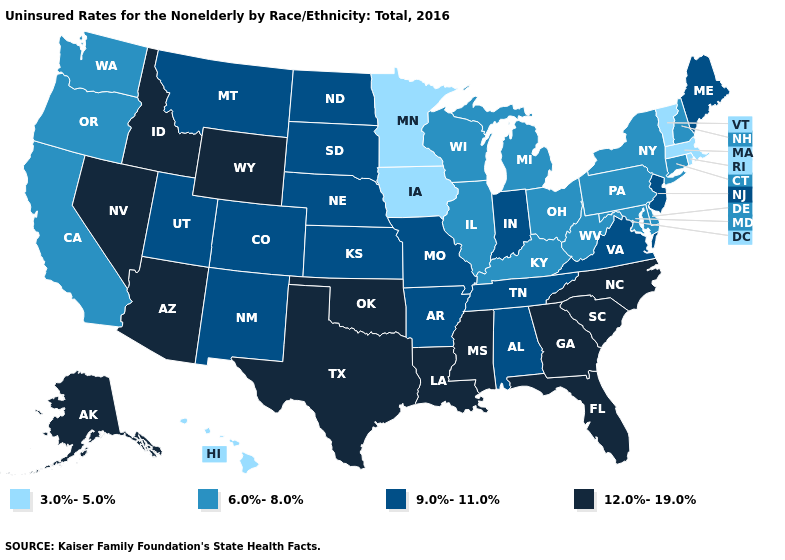Name the states that have a value in the range 12.0%-19.0%?
Concise answer only. Alaska, Arizona, Florida, Georgia, Idaho, Louisiana, Mississippi, Nevada, North Carolina, Oklahoma, South Carolina, Texas, Wyoming. Does Minnesota have the lowest value in the MidWest?
Keep it brief. Yes. Is the legend a continuous bar?
Give a very brief answer. No. What is the value of Texas?
Keep it brief. 12.0%-19.0%. Does Wyoming have a higher value than Louisiana?
Answer briefly. No. What is the lowest value in the Northeast?
Write a very short answer. 3.0%-5.0%. Does Maryland have the highest value in the USA?
Answer briefly. No. Does Washington have the lowest value in the USA?
Short answer required. No. Among the states that border Alabama , does Georgia have the highest value?
Give a very brief answer. Yes. Does Idaho have the highest value in the West?
Be succinct. Yes. What is the value of Rhode Island?
Quick response, please. 3.0%-5.0%. Name the states that have a value in the range 9.0%-11.0%?
Keep it brief. Alabama, Arkansas, Colorado, Indiana, Kansas, Maine, Missouri, Montana, Nebraska, New Jersey, New Mexico, North Dakota, South Dakota, Tennessee, Utah, Virginia. Which states have the lowest value in the USA?
Quick response, please. Hawaii, Iowa, Massachusetts, Minnesota, Rhode Island, Vermont. Which states have the highest value in the USA?
Be succinct. Alaska, Arizona, Florida, Georgia, Idaho, Louisiana, Mississippi, Nevada, North Carolina, Oklahoma, South Carolina, Texas, Wyoming. 